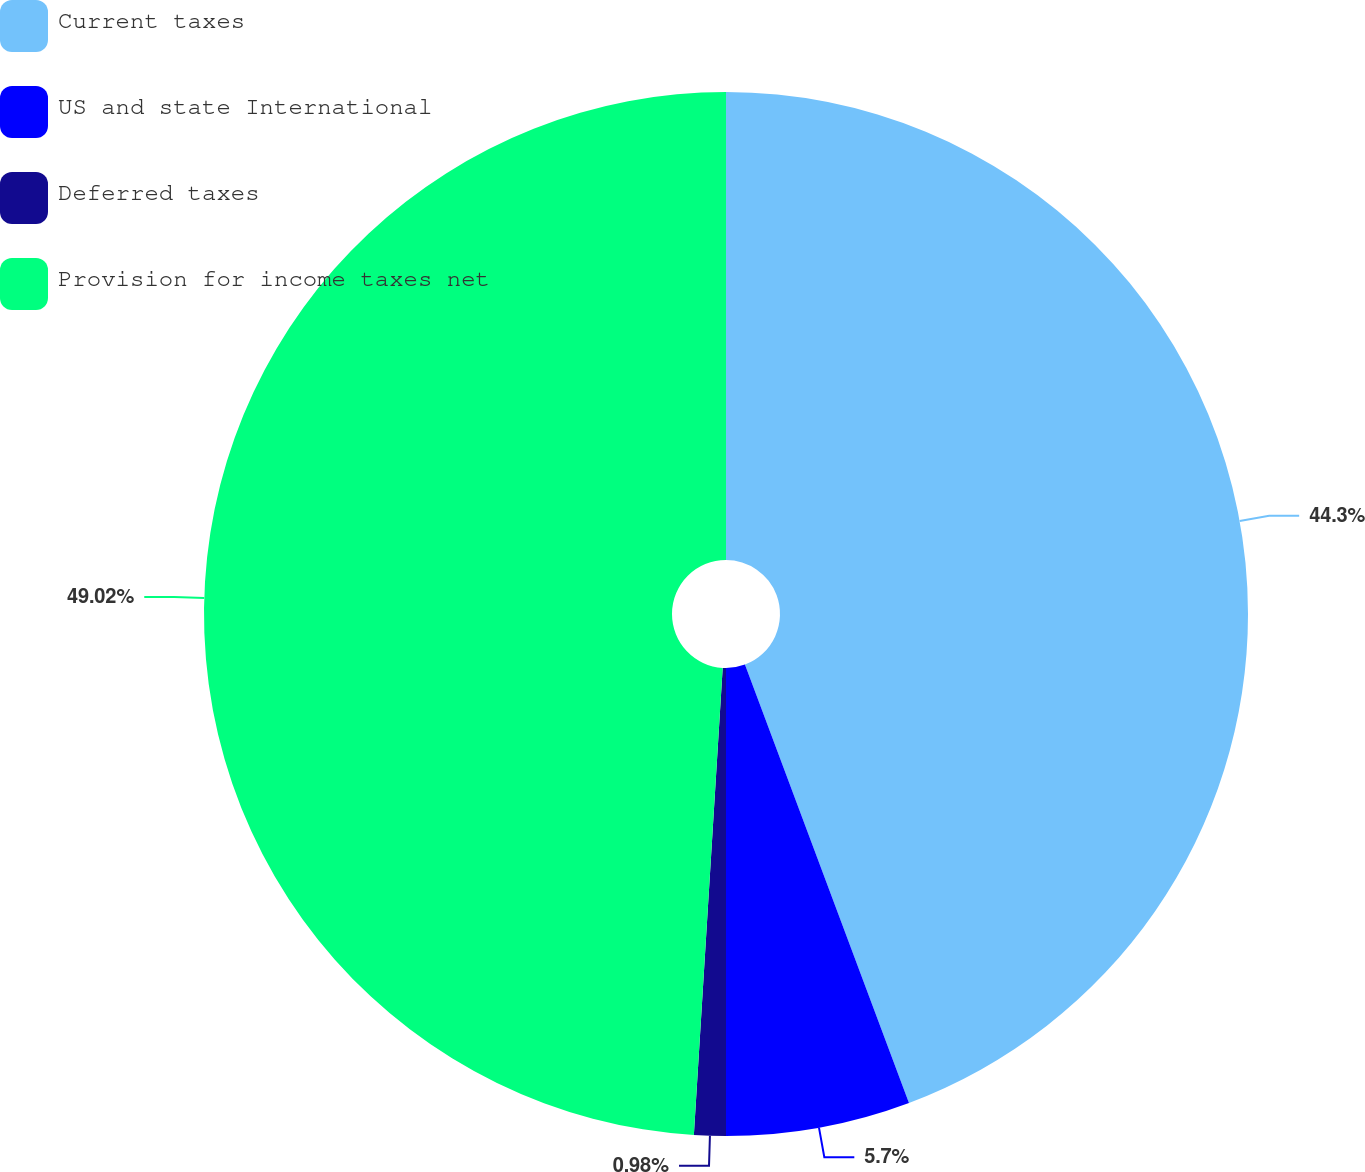Convert chart. <chart><loc_0><loc_0><loc_500><loc_500><pie_chart><fcel>Current taxes<fcel>US and state International<fcel>Deferred taxes<fcel>Provision for income taxes net<nl><fcel>44.3%<fcel>5.7%<fcel>0.98%<fcel>49.02%<nl></chart> 